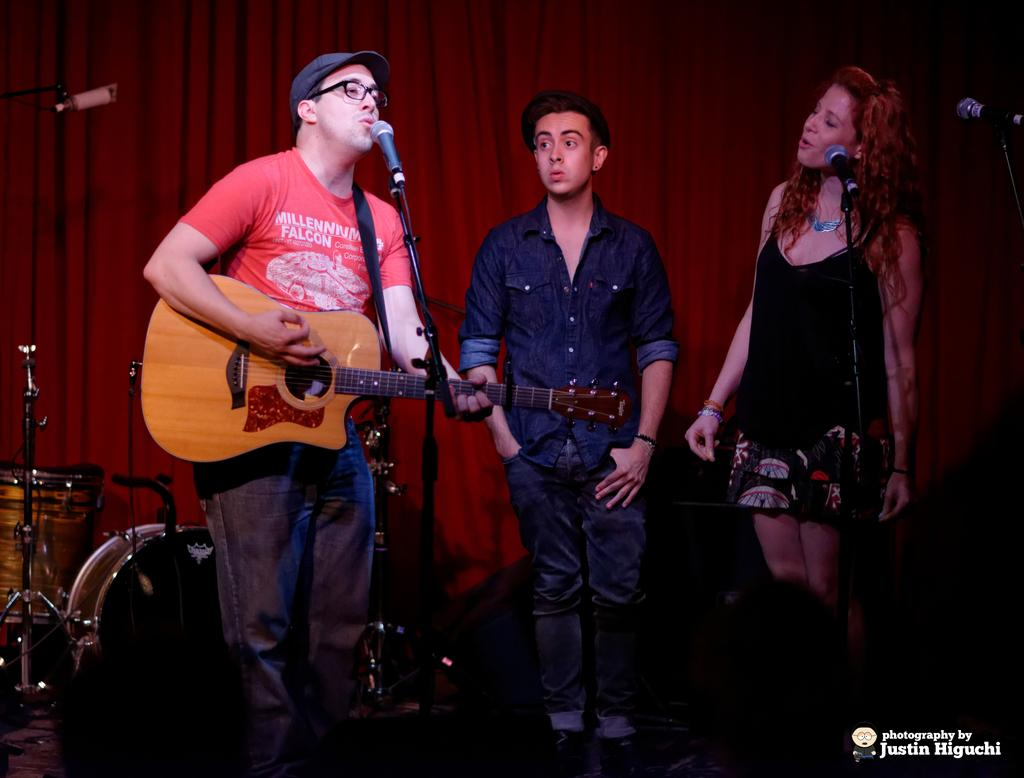How many people are in the image? There are three people in the image. What are the people doing in the image? The people are playing musical instruments. Can you describe the woman's position in the image? The woman is on the right side of the image. What is the woman doing in the image? The woman is singing a song. What can be observed about the woman's mouth in the image? The woman's mouth is open. What type of collar is the woman wearing in the image? There is no collar visible on the woman in the image. What genre of fiction is the woman reading from in the image? The woman is singing a song, not reading from any fiction in the image. 